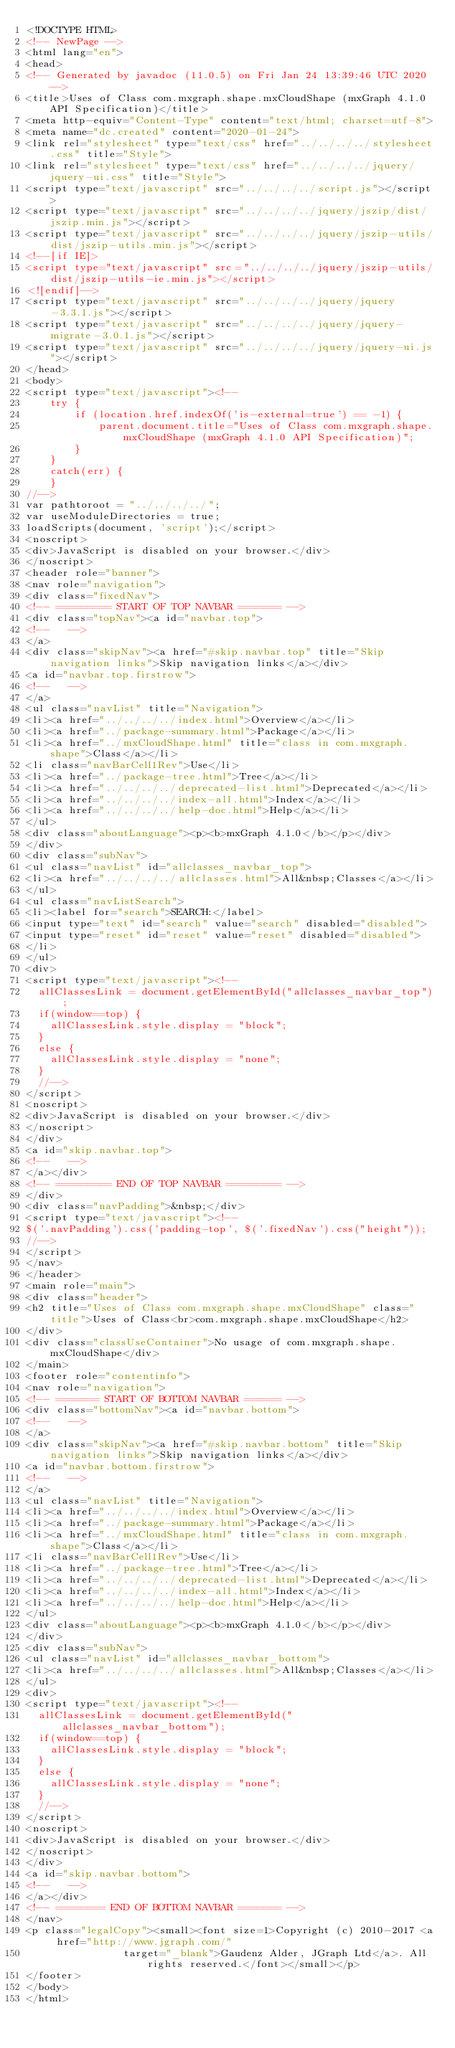<code> <loc_0><loc_0><loc_500><loc_500><_HTML_><!DOCTYPE HTML>
<!-- NewPage -->
<html lang="en">
<head>
<!-- Generated by javadoc (11.0.5) on Fri Jan 24 13:39:46 UTC 2020 -->
<title>Uses of Class com.mxgraph.shape.mxCloudShape (mxGraph 4.1.0 API Specification)</title>
<meta http-equiv="Content-Type" content="text/html; charset=utf-8">
<meta name="dc.created" content="2020-01-24">
<link rel="stylesheet" type="text/css" href="../../../../stylesheet.css" title="Style">
<link rel="stylesheet" type="text/css" href="../../../../jquery/jquery-ui.css" title="Style">
<script type="text/javascript" src="../../../../script.js"></script>
<script type="text/javascript" src="../../../../jquery/jszip/dist/jszip.min.js"></script>
<script type="text/javascript" src="../../../../jquery/jszip-utils/dist/jszip-utils.min.js"></script>
<!--[if IE]>
<script type="text/javascript" src="../../../../jquery/jszip-utils/dist/jszip-utils-ie.min.js"></script>
<![endif]-->
<script type="text/javascript" src="../../../../jquery/jquery-3.3.1.js"></script>
<script type="text/javascript" src="../../../../jquery/jquery-migrate-3.0.1.js"></script>
<script type="text/javascript" src="../../../../jquery/jquery-ui.js"></script>
</head>
<body>
<script type="text/javascript"><!--
    try {
        if (location.href.indexOf('is-external=true') == -1) {
            parent.document.title="Uses of Class com.mxgraph.shape.mxCloudShape (mxGraph 4.1.0 API Specification)";
        }
    }
    catch(err) {
    }
//-->
var pathtoroot = "../../../../";
var useModuleDirectories = true;
loadScripts(document, 'script');</script>
<noscript>
<div>JavaScript is disabled on your browser.</div>
</noscript>
<header role="banner">
<nav role="navigation">
<div class="fixedNav">
<!-- ========= START OF TOP NAVBAR ======= -->
<div class="topNav"><a id="navbar.top">
<!--   -->
</a>
<div class="skipNav"><a href="#skip.navbar.top" title="Skip navigation links">Skip navigation links</a></div>
<a id="navbar.top.firstrow">
<!--   -->
</a>
<ul class="navList" title="Navigation">
<li><a href="../../../../index.html">Overview</a></li>
<li><a href="../package-summary.html">Package</a></li>
<li><a href="../mxCloudShape.html" title="class in com.mxgraph.shape">Class</a></li>
<li class="navBarCell1Rev">Use</li>
<li><a href="../package-tree.html">Tree</a></li>
<li><a href="../../../../deprecated-list.html">Deprecated</a></li>
<li><a href="../../../../index-all.html">Index</a></li>
<li><a href="../../../../help-doc.html">Help</a></li>
</ul>
<div class="aboutLanguage"><p><b>mxGraph 4.1.0</b></p></div>
</div>
<div class="subNav">
<ul class="navList" id="allclasses_navbar_top">
<li><a href="../../../../allclasses.html">All&nbsp;Classes</a></li>
</ul>
<ul class="navListSearch">
<li><label for="search">SEARCH:</label>
<input type="text" id="search" value="search" disabled="disabled">
<input type="reset" id="reset" value="reset" disabled="disabled">
</li>
</ul>
<div>
<script type="text/javascript"><!--
  allClassesLink = document.getElementById("allclasses_navbar_top");
  if(window==top) {
    allClassesLink.style.display = "block";
  }
  else {
    allClassesLink.style.display = "none";
  }
  //-->
</script>
<noscript>
<div>JavaScript is disabled on your browser.</div>
</noscript>
</div>
<a id="skip.navbar.top">
<!--   -->
</a></div>
<!-- ========= END OF TOP NAVBAR ========= -->
</div>
<div class="navPadding">&nbsp;</div>
<script type="text/javascript"><!--
$('.navPadding').css('padding-top', $('.fixedNav').css("height"));
//-->
</script>
</nav>
</header>
<main role="main">
<div class="header">
<h2 title="Uses of Class com.mxgraph.shape.mxCloudShape" class="title">Uses of Class<br>com.mxgraph.shape.mxCloudShape</h2>
</div>
<div class="classUseContainer">No usage of com.mxgraph.shape.mxCloudShape</div>
</main>
<footer role="contentinfo">
<nav role="navigation">
<!-- ======= START OF BOTTOM NAVBAR ====== -->
<div class="bottomNav"><a id="navbar.bottom">
<!--   -->
</a>
<div class="skipNav"><a href="#skip.navbar.bottom" title="Skip navigation links">Skip navigation links</a></div>
<a id="navbar.bottom.firstrow">
<!--   -->
</a>
<ul class="navList" title="Navigation">
<li><a href="../../../../index.html">Overview</a></li>
<li><a href="../package-summary.html">Package</a></li>
<li><a href="../mxCloudShape.html" title="class in com.mxgraph.shape">Class</a></li>
<li class="navBarCell1Rev">Use</li>
<li><a href="../package-tree.html">Tree</a></li>
<li><a href="../../../../deprecated-list.html">Deprecated</a></li>
<li><a href="../../../../index-all.html">Index</a></li>
<li><a href="../../../../help-doc.html">Help</a></li>
</ul>
<div class="aboutLanguage"><p><b>mxGraph 4.1.0</b></p></div>
</div>
<div class="subNav">
<ul class="navList" id="allclasses_navbar_bottom">
<li><a href="../../../../allclasses.html">All&nbsp;Classes</a></li>
</ul>
<div>
<script type="text/javascript"><!--
  allClassesLink = document.getElementById("allclasses_navbar_bottom");
  if(window==top) {
    allClassesLink.style.display = "block";
  }
  else {
    allClassesLink.style.display = "none";
  }
  //-->
</script>
<noscript>
<div>JavaScript is disabled on your browser.</div>
</noscript>
</div>
<a id="skip.navbar.bottom">
<!--   -->
</a></div>
<!-- ======== END OF BOTTOM NAVBAR ======= -->
</nav>
<p class="legalCopy"><small><font size=1>Copyright (c) 2010-2017 <a href="http://www.jgraph.com/"
				target="_blank">Gaudenz Alder, JGraph Ltd</a>. All rights reserved.</font></small></p>
</footer>
</body>
</html>
</code> 